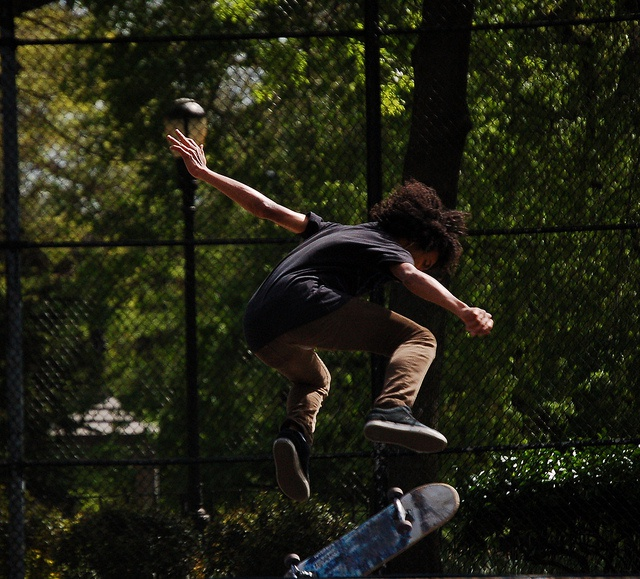Describe the objects in this image and their specific colors. I can see people in black, maroon, gray, and tan tones and skateboard in black, gray, navy, and blue tones in this image. 